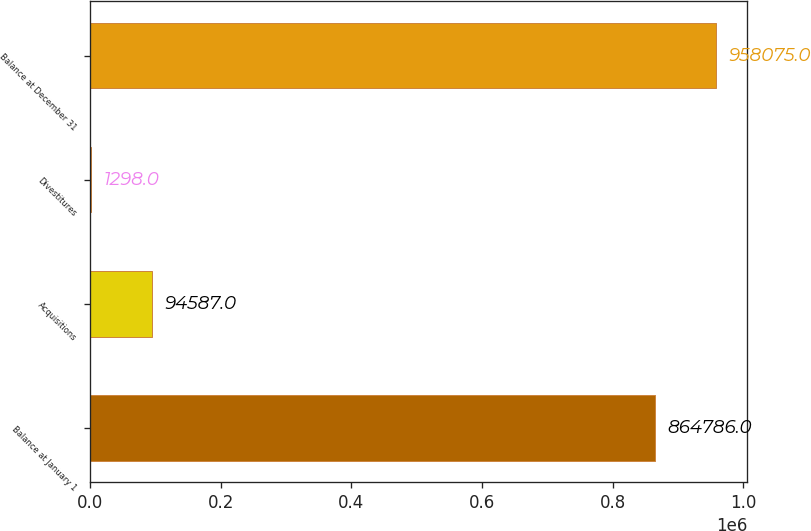Convert chart. <chart><loc_0><loc_0><loc_500><loc_500><bar_chart><fcel>Balance at January 1<fcel>Acquisitions<fcel>Divestitures<fcel>Balance at December 31<nl><fcel>864786<fcel>94587<fcel>1298<fcel>958075<nl></chart> 